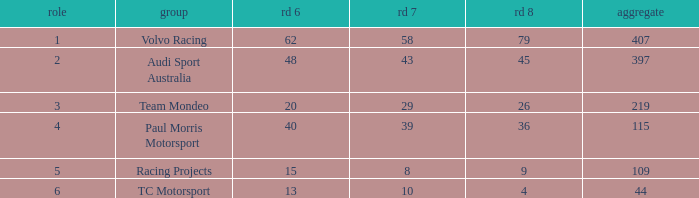What is the sum of values of Rd 7 with RD 6 less than 48 and Rd 8 less than 4 for TC Motorsport in a position greater than 1? None. 